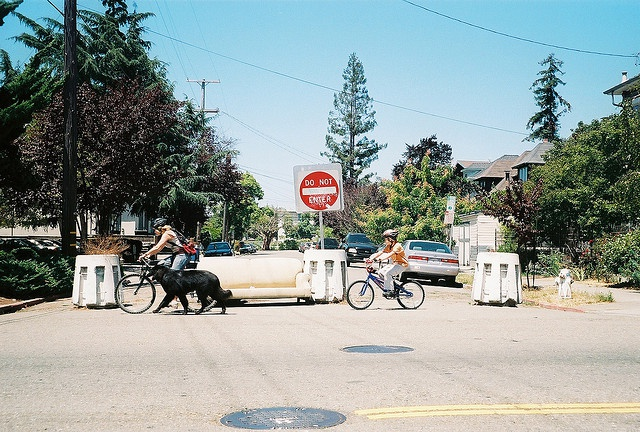Describe the objects in this image and their specific colors. I can see couch in teal, ivory, and tan tones, dog in teal, black, gray, ivory, and darkgray tones, car in teal, lightgray, black, and darkgray tones, bicycle in teal, lightgray, black, darkgray, and gray tones, and bicycle in teal, lightgray, black, darkgray, and tan tones in this image. 